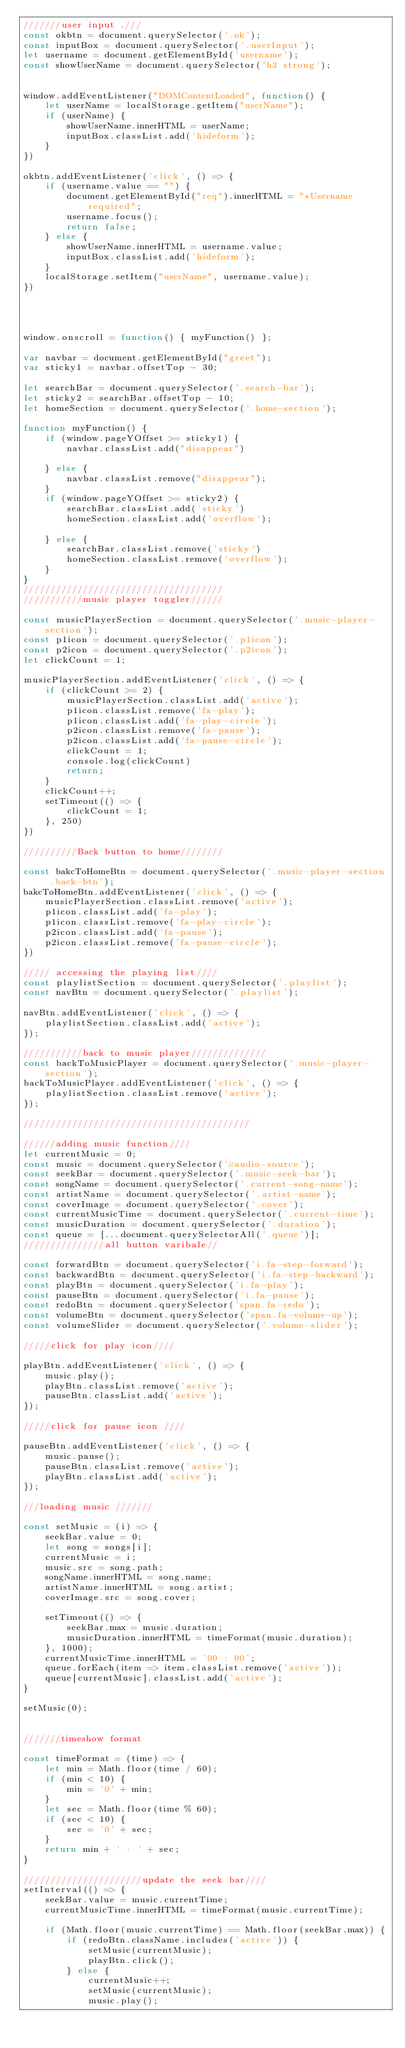<code> <loc_0><loc_0><loc_500><loc_500><_JavaScript_>///////user input .///
const okbtn = document.querySelector('.ok');
const inputBox = document.querySelector('.userInput');
let username = document.getElementById('username');
const showUserName = document.querySelector('h3 strong');


window.addEventListener("DOMContentLoaded", function() {
    let userName = localStorage.getItem("userName");
    if (userName) {
        showUserName.innerHTML = userName;
        inputBox.classList.add('hideform');
    }
})

okbtn.addEventListener('click', () => {
    if (username.value == "") {
        document.getElementById("req").innerHTML = "*Username required";
        username.focus();
        return false;
    } else {
        showUserName.innerHTML = username.value;
        inputBox.classList.add('hideform');
    }
    localStorage.setItem("userName", username.value);
})




window.onscroll = function() { myFunction() };

var navbar = document.getElementById("greet");
var sticky1 = navbar.offsetTop - 30;

let searchBar = document.querySelector('.search-bar');
let sticky2 = searchBar.offsetTop - 10;
let homeSection = document.querySelector('.home-section');

function myFunction() {
    if (window.pageYOffset >= sticky1) {
        navbar.classList.add("disappear")

    } else {
        navbar.classList.remove("disappear");
    }
    if (window.pageYOffset >= sticky2) {
        searchBar.classList.add('sticky')
        homeSection.classList.add('overflow');

    } else {
        searchBar.classList.remove('sticky')
        homeSection.classList.remove('overflow');
    }
}
/////////////////////////////////////
///////////music player toggler//////

const musicPlayerSection = document.querySelector('.music-player-section');
const p1icon = document.querySelector('.p1icon');
const p2icon = document.querySelector('.p2icon');
let clickCount = 1;

musicPlayerSection.addEventListener('click', () => {
    if (clickCount >= 2) {
        musicPlayerSection.classList.add('active');
        p1icon.classList.remove('fa-play');
        p1icon.classList.add('fa-play-circle');
        p2icon.classList.remove('fa-pause');
        p2icon.classList.add('fa-pause-circle');
        clickCount = 1;
        console.log(clickCount)
        return;
    }
    clickCount++;
    setTimeout(() => {
        clickCount = 1;
    }, 250)
})

//////////Back button to home////////

const bakcToHomeBtn = document.querySelector('.music-player-section .back-btn');
bakcToHomeBtn.addEventListener('click', () => {
    musicPlayerSection.classList.remove('active');
    p1icon.classList.add('fa-play');
    p1icon.classList.remove('fa-play-circle');
    p2icon.classList.add('fa-pause');
    p2icon.classList.remove('fa-pause-circle');
})

///// accessing the playing list////
const playlistSection = document.querySelector('.playlist');
const navBtn = document.querySelector('.playlist');

navBtn.addEventListener('click', () => {
    playlistSection.classList.add('active');
});

///////////back to music player//////////////
const backToMusicPlayer = document.querySelector('.music-player-section');
backToMusicPlayer.addEventListener('click', () => {
    playlistSection.classList.remove('active');
});

//////////////////////////////////////////

//////adding music function////
let currentMusic = 0;
const music = document.querySelector('#audio-source');
const seekBar = document.querySelector('.music-seek-bar');
const songName = document.querySelector('.current-song-name');
const artistName = document.querySelector('.artist-name');
const coverImage = document.querySelector('.cover');
const currentMusicTime = document.querySelector('.current-time');
const musicDuration = document.querySelector('.duration');
const queue = [...document.querySelectorAll('.queue')];
///////////////all button varibale//

const forwardBtn = document.querySelector('i.fa-step-forward');
const backwardBtn = document.querySelector('i.fa-step-backward');
const playBtn = document.querySelector('i.fa-play');
const pauseBtn = document.querySelector('i.fa-pause');
const redoBtn = document.querySelector('span.fa-redo');
const volumeBtn = document.querySelector('span.fa-volume-up');
const volumeSlider = document.querySelector('.volume-slider');

/////click for play icon////

playBtn.addEventListener('click', () => {
    music.play();
    playBtn.classList.remove('active');
    pauseBtn.classList.add('active');
});

/////click for pause icon ////

pauseBtn.addEventListener('click', () => {
    music.pause();
    pauseBtn.classList.remove('active');
    playBtn.classList.add('active');
});

///loading music ///////

const setMusic = (i) => {
    seekBar.value = 0;
    let song = songs[i];
    currentMusic = i;
    music.src = song.path;
    songName.innerHTML = song.name;
    artistName.innerHTML = song.artist;
    coverImage.src = song.cover;

    setTimeout(() => {
        seekBar.max = music.duration;
        musicDuration.innerHTML = timeFormat(music.duration);
    }, 1000);
    currentMusicTime.innerHTML = '00 : 00';
    queue.forEach(item => item.classList.remove('active'));
    queue[currentMusic].classList.add('active');
}

setMusic(0);


///////timeshow format

const timeFormat = (time) => {
    let min = Math.floor(time / 60);
    if (min < 10) {
        min = '0' + min;
    }
    let sec = Math.floor(time % 60);
    if (sec < 10) {
        sec = '0' + sec;
    }
    return min + ' : ' + sec;
}

//////////////////////update the seek bar////
setInterval(() => {
    seekBar.value = music.currentTime;
    currentMusicTime.innerHTML = timeFormat(music.currentTime);

    if (Math.floor(music.currentTime) == Math.floor(seekBar.max)) {
        if (redoBtn.className.includes('active')) {
            setMusic(currentMusic);
            playBtn.click();
        } else {
            currentMusic++;
            setMusic(currentMusic);
            music.play();</code> 